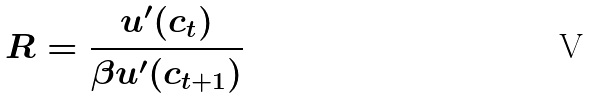<formula> <loc_0><loc_0><loc_500><loc_500>R = \frac { u ^ { \prime } ( c _ { t } ) } { \beta u ^ { \prime } ( c _ { t + 1 } ) }</formula> 